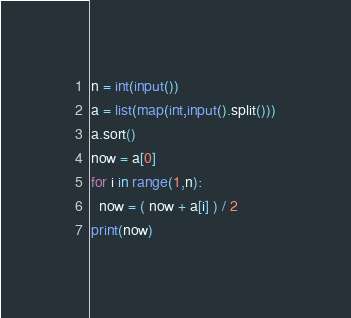<code> <loc_0><loc_0><loc_500><loc_500><_Python_>n = int(input())
a = list(map(int,input().split()))
a.sort()
now = a[0]
for i in range(1,n):
  now = ( now + a[i] ) / 2
print(now)</code> 